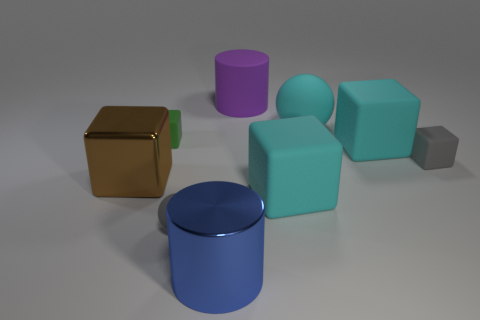How big is the gray matte ball in front of the tiny green rubber thing?
Your response must be concise. Small. There is a cyan object in front of the metallic block; does it have the same size as the small gray sphere?
Your answer should be compact. No. Are there any other things that have the same color as the shiny cube?
Ensure brevity in your answer.  No. What shape is the big purple matte object?
Offer a terse response. Cylinder. What number of objects are in front of the matte cylinder and right of the green rubber block?
Provide a short and direct response. 6. What is the material of the purple object that is the same shape as the blue thing?
Your answer should be very brief. Rubber. Are there the same number of large brown metallic cubes that are behind the cyan rubber ball and tiny green rubber cubes that are behind the green matte object?
Provide a short and direct response. Yes. Does the small sphere have the same material as the brown cube?
Provide a succinct answer. No. What number of green objects are metal cubes or small rubber blocks?
Your answer should be very brief. 1. What number of purple rubber things have the same shape as the brown metallic thing?
Offer a very short reply. 0. 